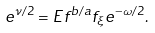Convert formula to latex. <formula><loc_0><loc_0><loc_500><loc_500>e ^ { \nu / 2 } = E f ^ { b / a } f _ { \xi } e ^ { - \omega / 2 } .</formula> 